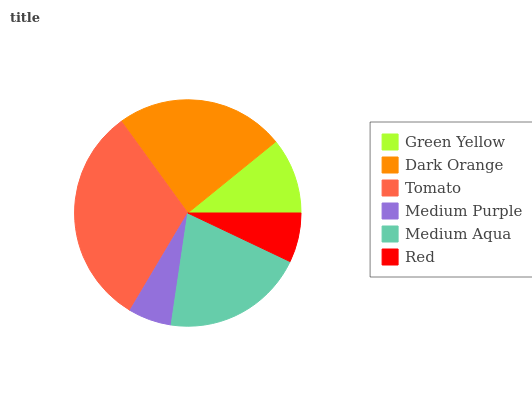Is Medium Purple the minimum?
Answer yes or no. Yes. Is Tomato the maximum?
Answer yes or no. Yes. Is Dark Orange the minimum?
Answer yes or no. No. Is Dark Orange the maximum?
Answer yes or no. No. Is Dark Orange greater than Green Yellow?
Answer yes or no. Yes. Is Green Yellow less than Dark Orange?
Answer yes or no. Yes. Is Green Yellow greater than Dark Orange?
Answer yes or no. No. Is Dark Orange less than Green Yellow?
Answer yes or no. No. Is Medium Aqua the high median?
Answer yes or no. Yes. Is Green Yellow the low median?
Answer yes or no. Yes. Is Green Yellow the high median?
Answer yes or no. No. Is Tomato the low median?
Answer yes or no. No. 